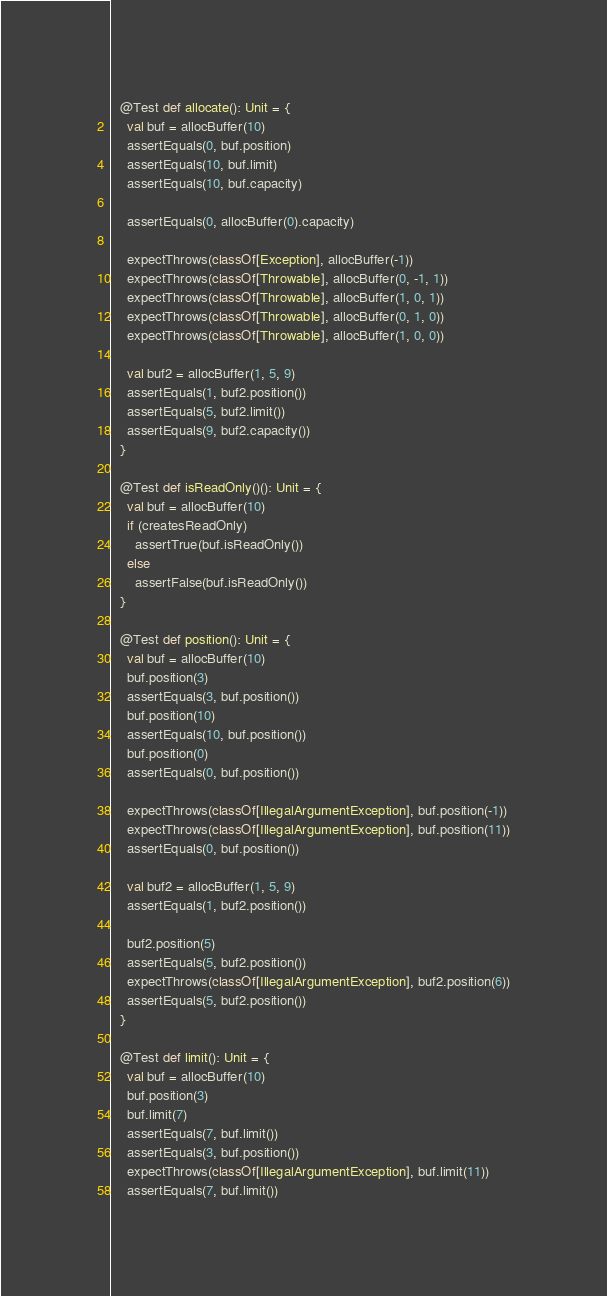Convert code to text. <code><loc_0><loc_0><loc_500><loc_500><_Scala_>  @Test def allocate(): Unit = {
    val buf = allocBuffer(10)
    assertEquals(0, buf.position)
    assertEquals(10, buf.limit)
    assertEquals(10, buf.capacity)

    assertEquals(0, allocBuffer(0).capacity)

    expectThrows(classOf[Exception], allocBuffer(-1))
    expectThrows(classOf[Throwable], allocBuffer(0, -1, 1))
    expectThrows(classOf[Throwable], allocBuffer(1, 0, 1))
    expectThrows(classOf[Throwable], allocBuffer(0, 1, 0))
    expectThrows(classOf[Throwable], allocBuffer(1, 0, 0))

    val buf2 = allocBuffer(1, 5, 9)
    assertEquals(1, buf2.position())
    assertEquals(5, buf2.limit())
    assertEquals(9, buf2.capacity())
  }

  @Test def isReadOnly()(): Unit = {
    val buf = allocBuffer(10)
    if (createsReadOnly)
      assertTrue(buf.isReadOnly())
    else
      assertFalse(buf.isReadOnly())
  }

  @Test def position(): Unit = {
    val buf = allocBuffer(10)
    buf.position(3)
    assertEquals(3, buf.position())
    buf.position(10)
    assertEquals(10, buf.position())
    buf.position(0)
    assertEquals(0, buf.position())

    expectThrows(classOf[IllegalArgumentException], buf.position(-1))
    expectThrows(classOf[IllegalArgumentException], buf.position(11))
    assertEquals(0, buf.position())

    val buf2 = allocBuffer(1, 5, 9)
    assertEquals(1, buf2.position())

    buf2.position(5)
    assertEquals(5, buf2.position())
    expectThrows(classOf[IllegalArgumentException], buf2.position(6))
    assertEquals(5, buf2.position())
  }

  @Test def limit(): Unit = {
    val buf = allocBuffer(10)
    buf.position(3)
    buf.limit(7)
    assertEquals(7, buf.limit())
    assertEquals(3, buf.position())
    expectThrows(classOf[IllegalArgumentException], buf.limit(11))
    assertEquals(7, buf.limit())</code> 